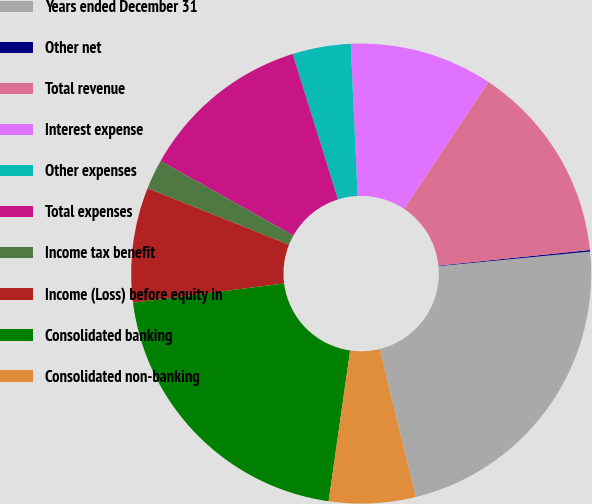Convert chart to OTSL. <chart><loc_0><loc_0><loc_500><loc_500><pie_chart><fcel>Years ended December 31<fcel>Other net<fcel>Total revenue<fcel>Interest expense<fcel>Other expenses<fcel>Total expenses<fcel>Income tax benefit<fcel>Income (Loss) before equity in<fcel>Consolidated banking<fcel>Consolidated non-banking<nl><fcel>22.71%<fcel>0.11%<fcel>14.03%<fcel>10.06%<fcel>4.09%<fcel>12.05%<fcel>2.1%<fcel>8.07%<fcel>20.72%<fcel>6.08%<nl></chart> 